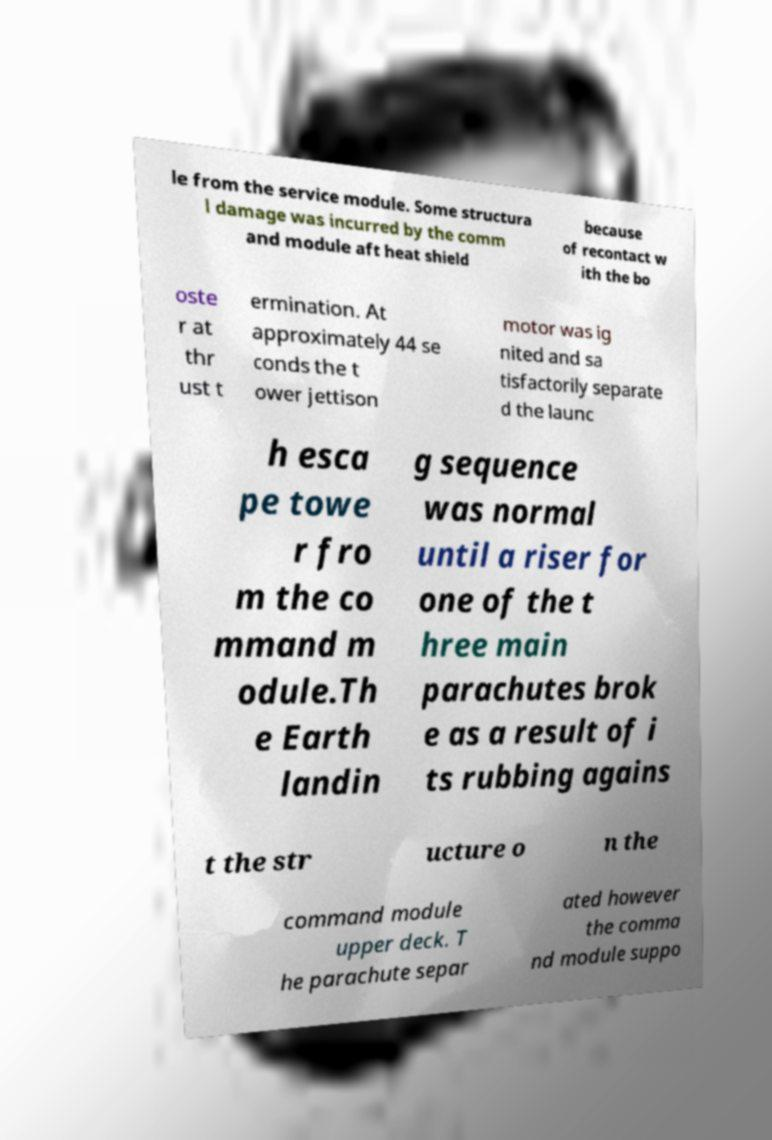Can you accurately transcribe the text from the provided image for me? le from the service module. Some structura l damage was incurred by the comm and module aft heat shield because of recontact w ith the bo oste r at thr ust t ermination. At approximately 44 se conds the t ower jettison motor was ig nited and sa tisfactorily separate d the launc h esca pe towe r fro m the co mmand m odule.Th e Earth landin g sequence was normal until a riser for one of the t hree main parachutes brok e as a result of i ts rubbing agains t the str ucture o n the command module upper deck. T he parachute separ ated however the comma nd module suppo 